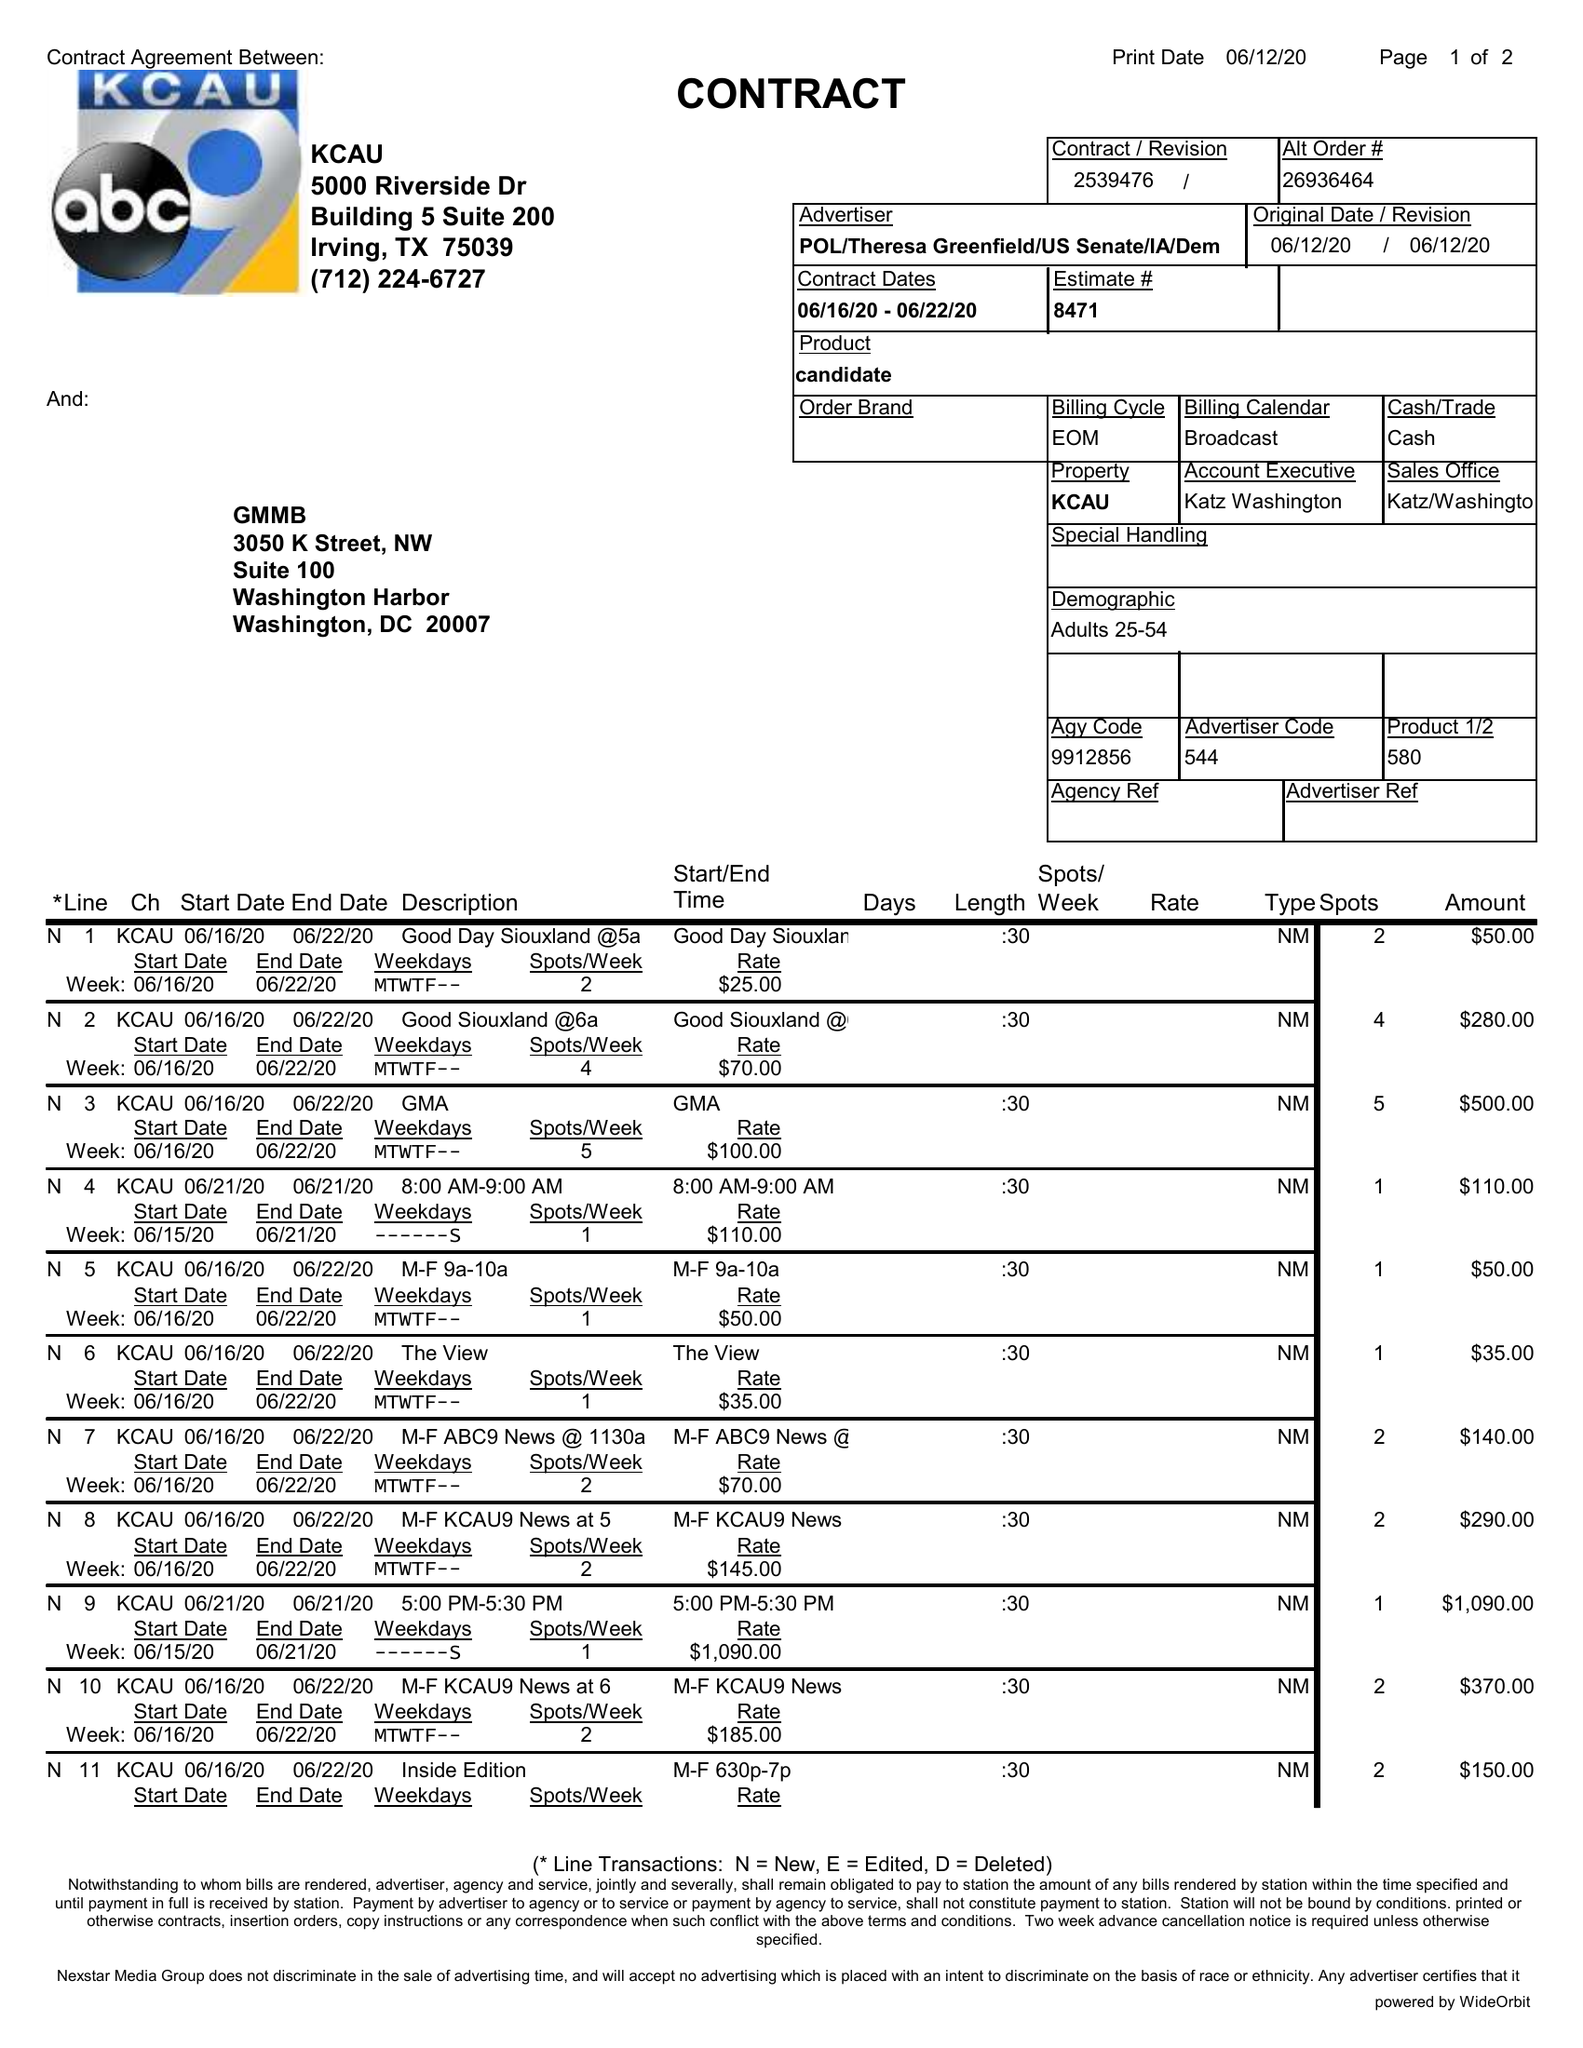What is the value for the flight_from?
Answer the question using a single word or phrase. 06/16/20 